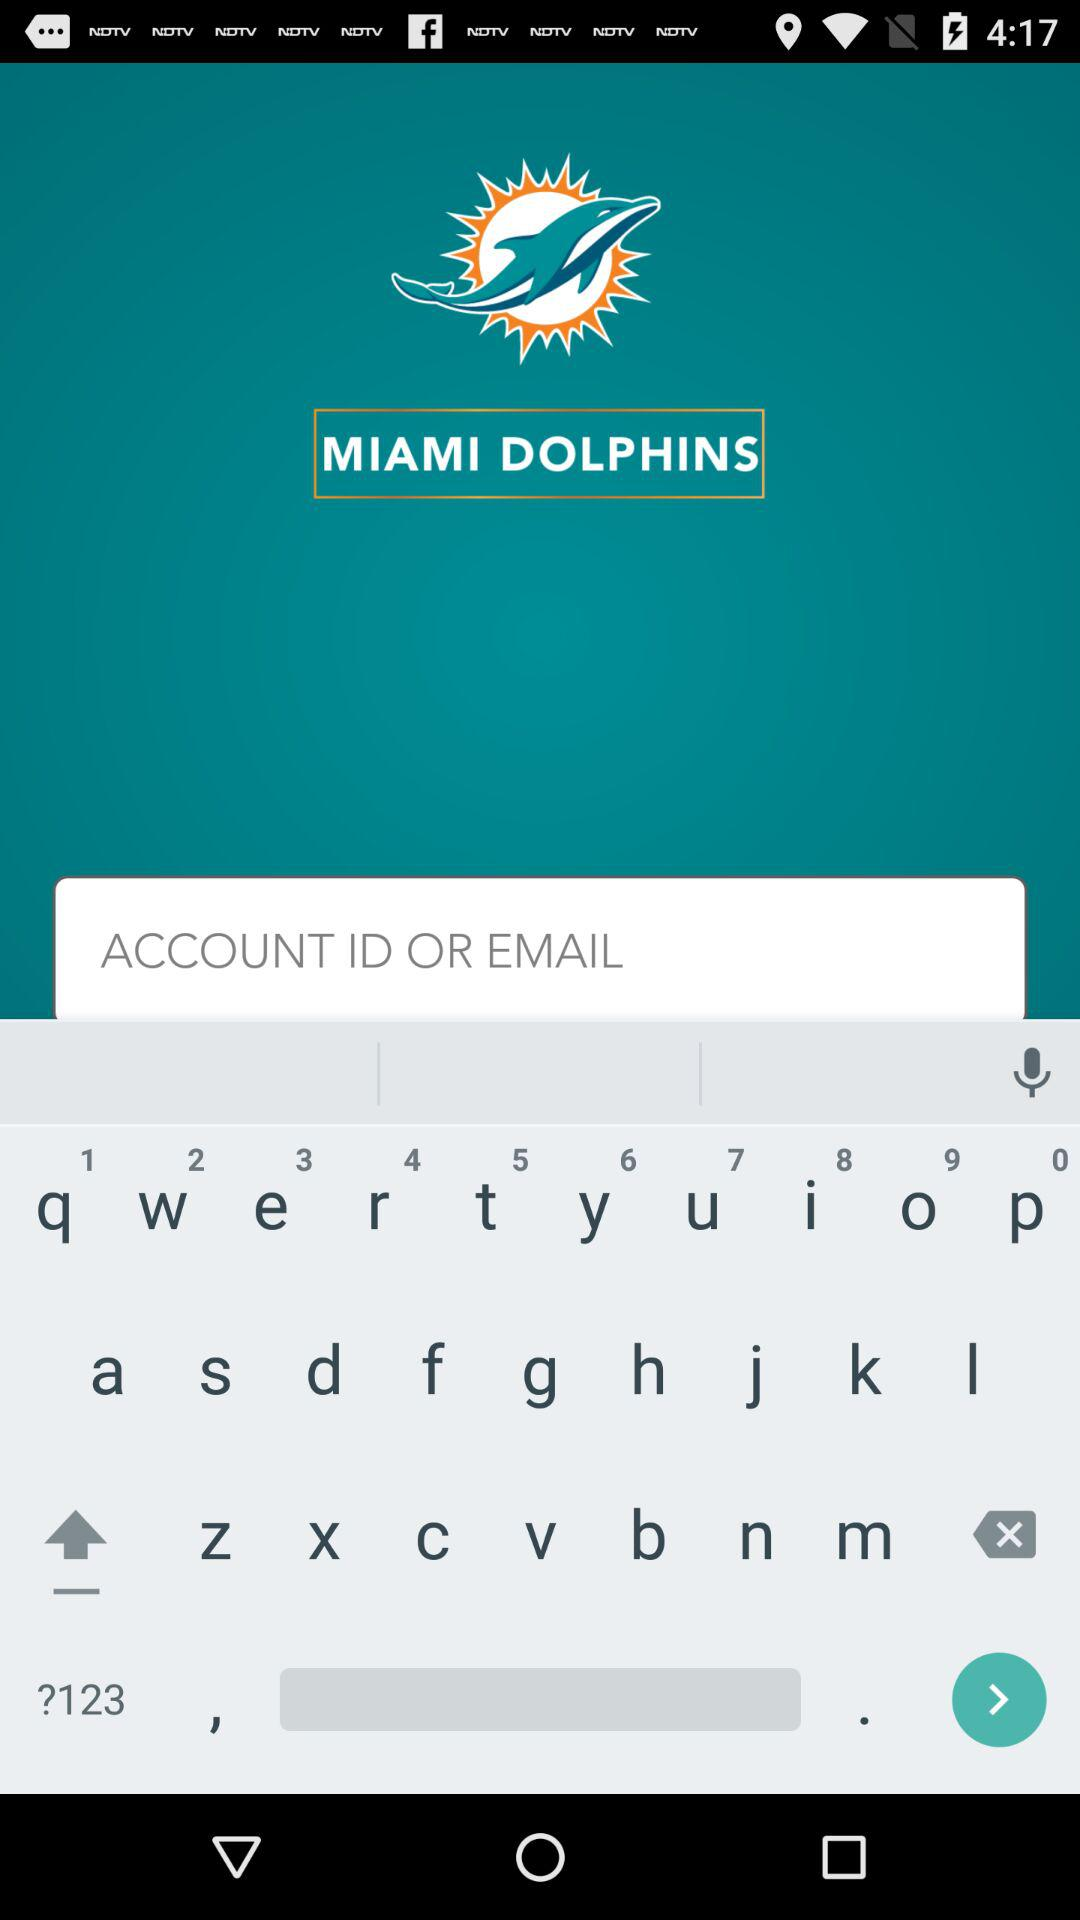What is the user name? The user name is Millio O.. 